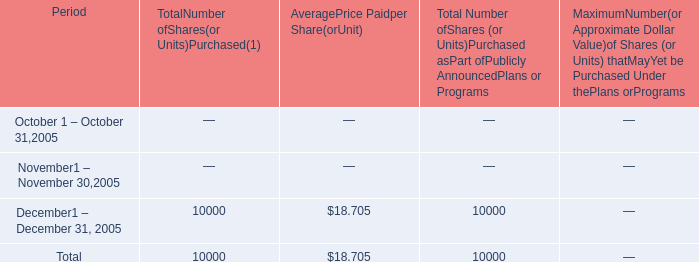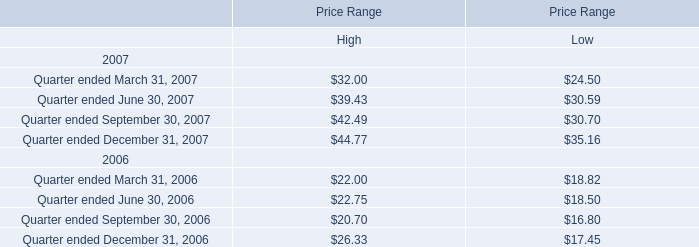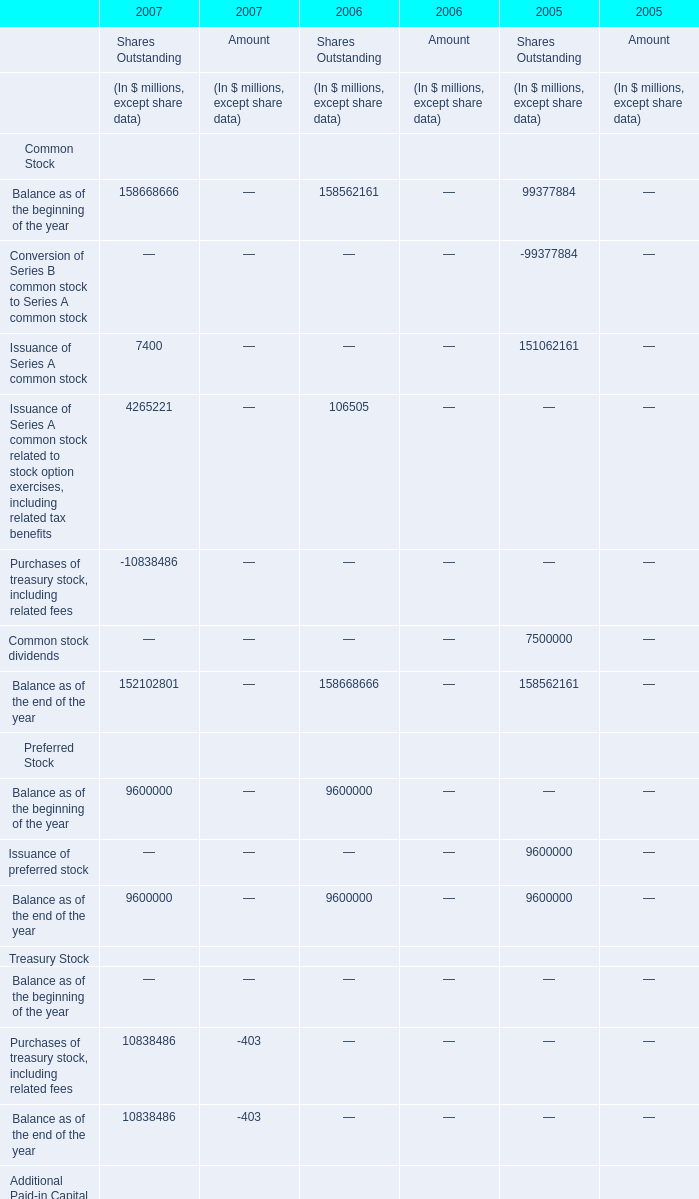When is Balance as of the beginning of the year of Shares Outstandings the largest? 
Answer: 2007. 